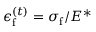<formula> <loc_0><loc_0><loc_500><loc_500>\epsilon _ { f } ^ { ( t ) } = { \sigma _ { f } } / { E ^ { * } }</formula> 